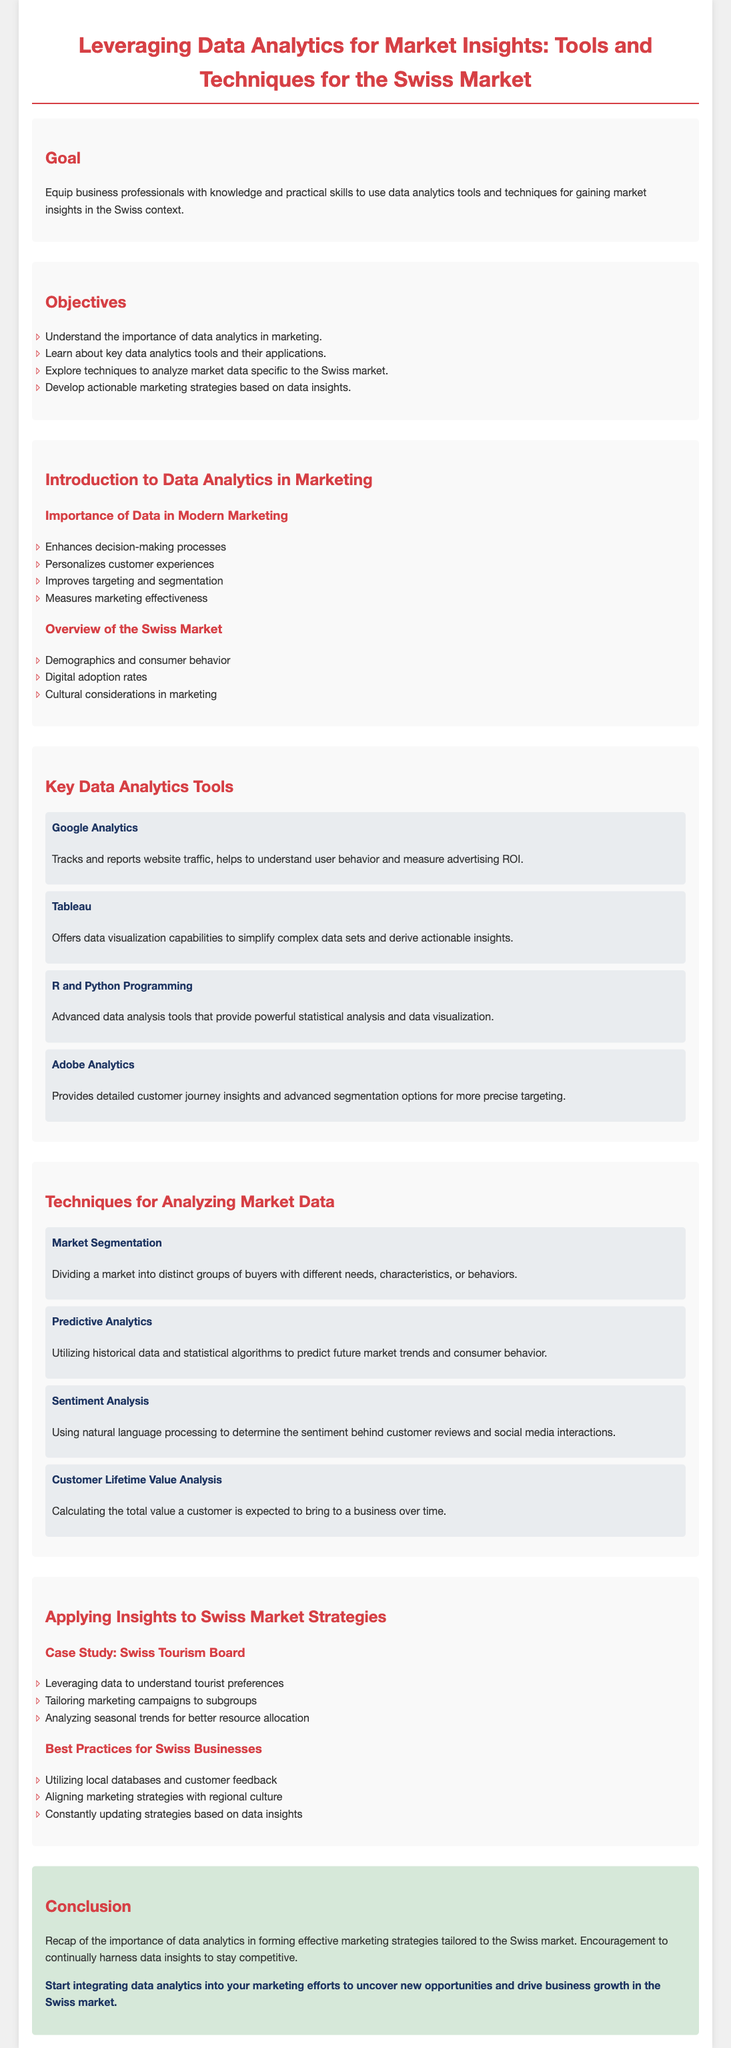what is the title of the lesson plan? The title is stated at the top of the document and outlines the main focus of the lesson.
Answer: Leveraging Data Analytics for Market Insights: Tools and Techniques for the Swiss Market what is one key objective of the lesson plan? The document lists several objectives and one can be selected from the objective list.
Answer: Understand the importance of data analytics in marketing name one data analytics tool mentioned in the lesson plan. The section on key data analytics tools provides several examples.
Answer: Google Analytics what technique is used for determining the sentiment behind customer reviews? The techniques section describes various methods, and this specific technique is mentioned.
Answer: Sentiment Analysis how does data analytics enhance decision-making processes? The document explains the importance of data in modern marketing with specific benefits.
Answer: Enhances decision-making processes what organization is used as a case study in the lesson plan? The case study section specifies the organization that exemplifies the application of data analytics.
Answer: Swiss Tourism Board what color is used for headings throughout the document? The document describes the color scheme used for headings in the style section.
Answer: D64045 how are marketing strategies suggested to align in the document? The best practices segment talks about aligning strategies with certain characteristics of the market.
Answer: Regional culture what is the call-to-action in the conclusion? The conclusion contains a specific call-to-action for the reader to engage with data analytics.
Answer: Start integrating data analytics into your marketing efforts 